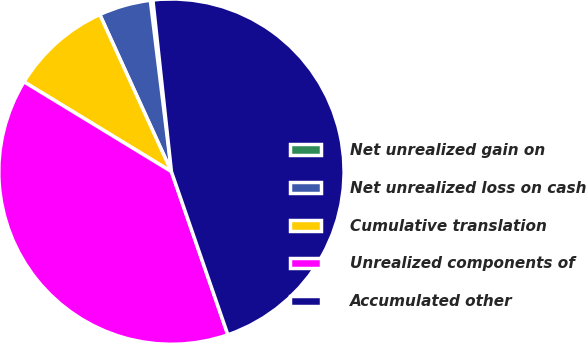Convert chart to OTSL. <chart><loc_0><loc_0><loc_500><loc_500><pie_chart><fcel>Net unrealized gain on<fcel>Net unrealized loss on cash<fcel>Cumulative translation<fcel>Unrealized components of<fcel>Accumulated other<nl><fcel>0.24%<fcel>4.86%<fcel>9.48%<fcel>39.01%<fcel>46.41%<nl></chart> 